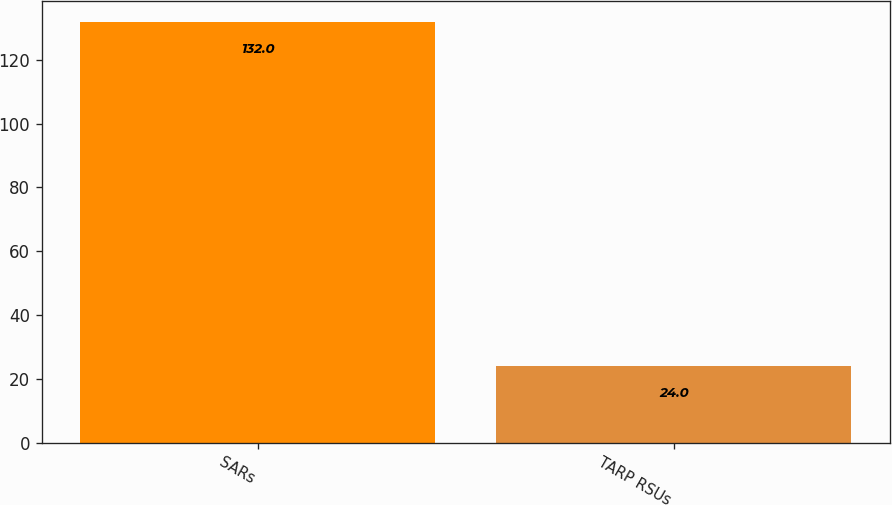Convert chart to OTSL. <chart><loc_0><loc_0><loc_500><loc_500><bar_chart><fcel>SARs<fcel>TARP RSUs<nl><fcel>132<fcel>24<nl></chart> 